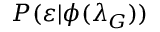Convert formula to latex. <formula><loc_0><loc_0><loc_500><loc_500>P ( \varepsilon | \phi ( \lambda _ { G } ) )</formula> 